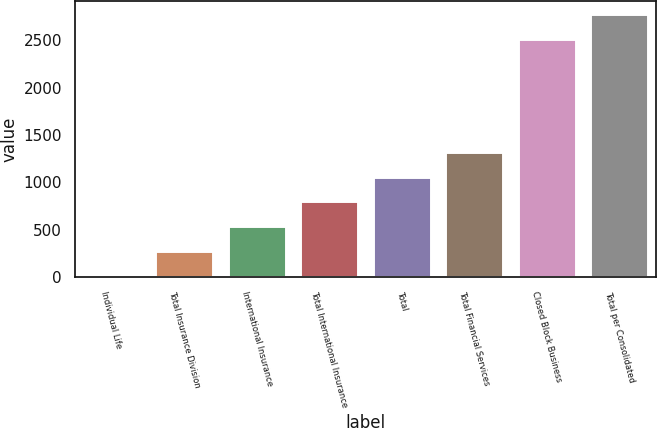Convert chart. <chart><loc_0><loc_0><loc_500><loc_500><bar_chart><fcel>Individual Life<fcel>Total Insurance Division<fcel>International Insurance<fcel>Total International Insurance<fcel>Total<fcel>Total Financial Services<fcel>Closed Block Business<fcel>Total per Consolidated<nl><fcel>20<fcel>280.2<fcel>540.4<fcel>800.6<fcel>1060.8<fcel>1321<fcel>2518<fcel>2778.2<nl></chart> 